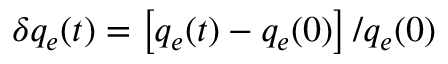<formula> <loc_0><loc_0><loc_500><loc_500>\delta q _ { e } ( t ) = \left [ q _ { e } ( t ) - q _ { e } ( 0 ) \right ] / q _ { e } ( 0 )</formula> 